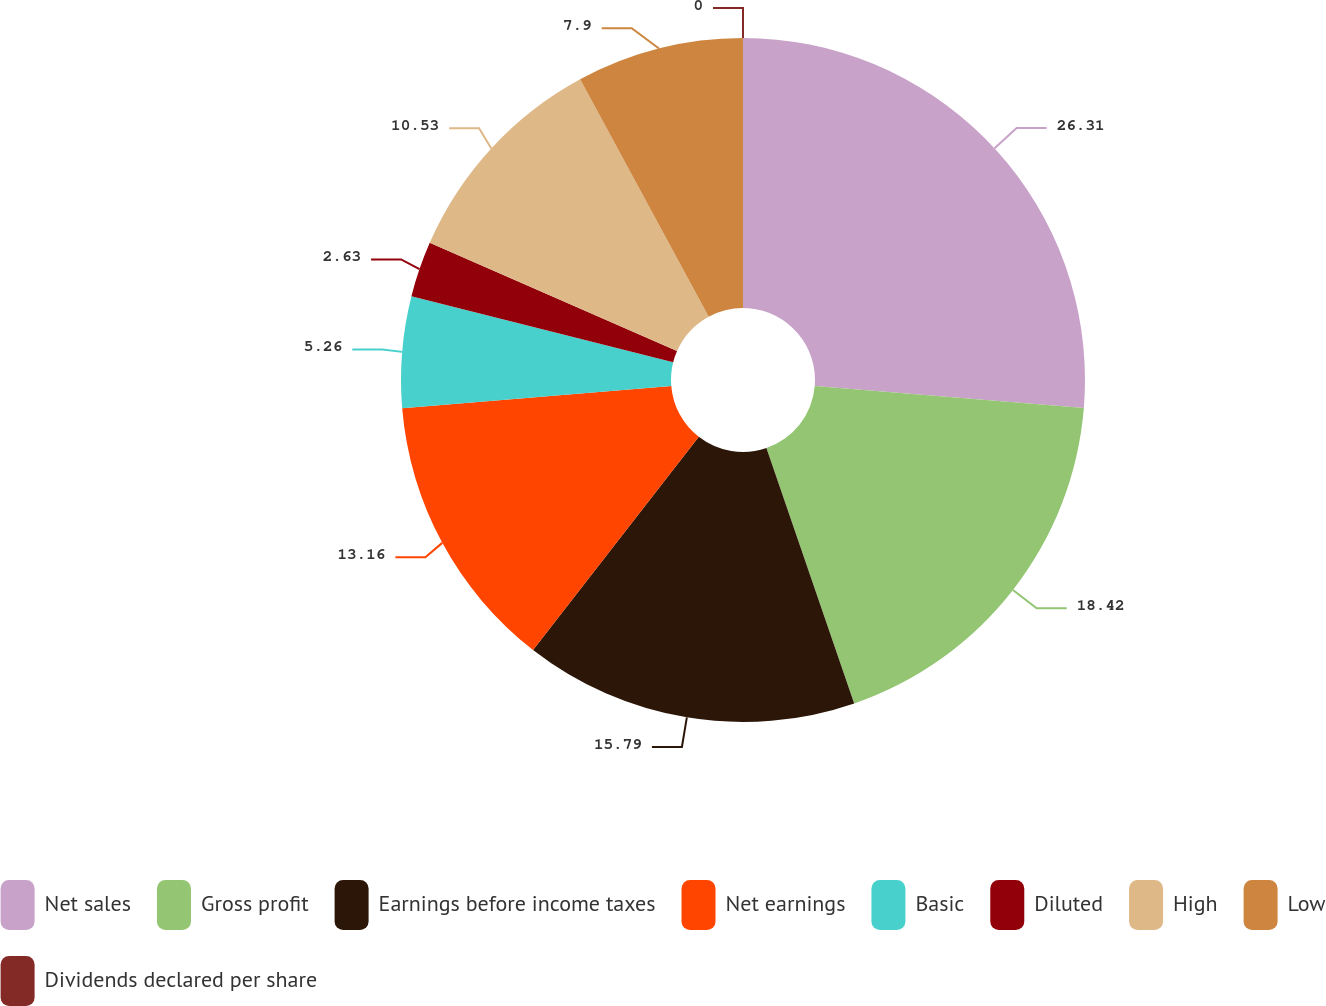Convert chart to OTSL. <chart><loc_0><loc_0><loc_500><loc_500><pie_chart><fcel>Net sales<fcel>Gross profit<fcel>Earnings before income taxes<fcel>Net earnings<fcel>Basic<fcel>Diluted<fcel>High<fcel>Low<fcel>Dividends declared per share<nl><fcel>26.31%<fcel>18.42%<fcel>15.79%<fcel>13.16%<fcel>5.26%<fcel>2.63%<fcel>10.53%<fcel>7.9%<fcel>0.0%<nl></chart> 